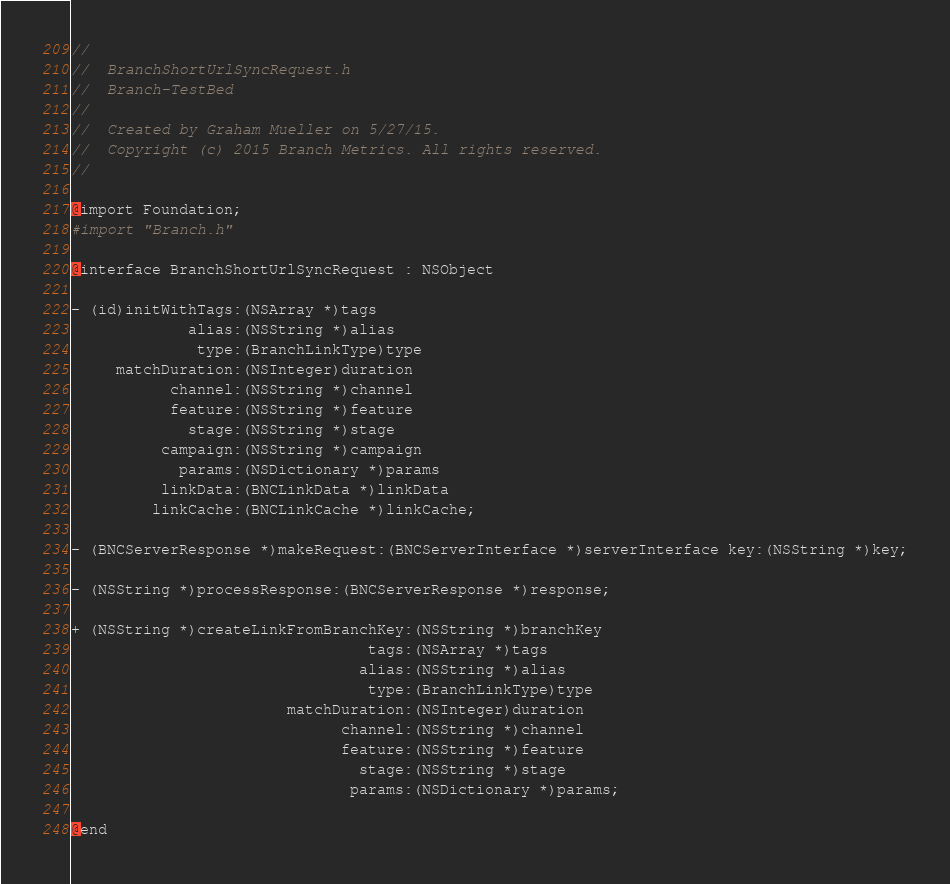<code> <loc_0><loc_0><loc_500><loc_500><_C_>//
//  BranchShortUrlSyncRequest.h
//  Branch-TestBed
//
//  Created by Graham Mueller on 5/27/15.
//  Copyright (c) 2015 Branch Metrics. All rights reserved.
//

@import Foundation;
#import "Branch.h"

@interface BranchShortUrlSyncRequest : NSObject

- (id)initWithTags:(NSArray *)tags
             alias:(NSString *)alias
              type:(BranchLinkType)type
     matchDuration:(NSInteger)duration
           channel:(NSString *)channel
           feature:(NSString *)feature
             stage:(NSString *)stage
          campaign:(NSString *)campaign
            params:(NSDictionary *)params
          linkData:(BNCLinkData *)linkData
         linkCache:(BNCLinkCache *)linkCache;

- (BNCServerResponse *)makeRequest:(BNCServerInterface *)serverInterface key:(NSString *)key;

- (NSString *)processResponse:(BNCServerResponse *)response;

+ (NSString *)createLinkFromBranchKey:(NSString *)branchKey
                                 tags:(NSArray *)tags
                                alias:(NSString *)alias
                                 type:(BranchLinkType)type
                        matchDuration:(NSInteger)duration
                              channel:(NSString *)channel
                              feature:(NSString *)feature
                                stage:(NSString *)stage
                               params:(NSDictionary *)params;

@end
</code> 